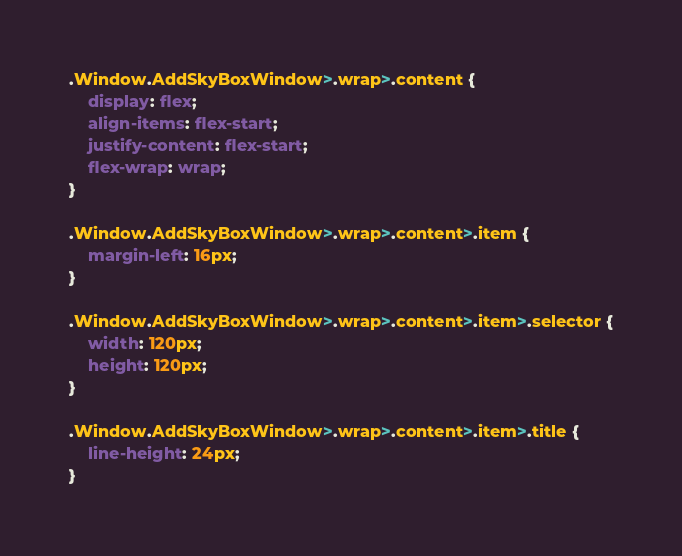Convert code to text. <code><loc_0><loc_0><loc_500><loc_500><_CSS_>.Window.AddSkyBoxWindow>.wrap>.content {
    display: flex;
    align-items: flex-start;
    justify-content: flex-start;
    flex-wrap: wrap;
}

.Window.AddSkyBoxWindow>.wrap>.content>.item {
    margin-left: 16px;
}

.Window.AddSkyBoxWindow>.wrap>.content>.item>.selector {
    width: 120px;
    height: 120px;
}

.Window.AddSkyBoxWindow>.wrap>.content>.item>.title {
    line-height: 24px;
}</code> 